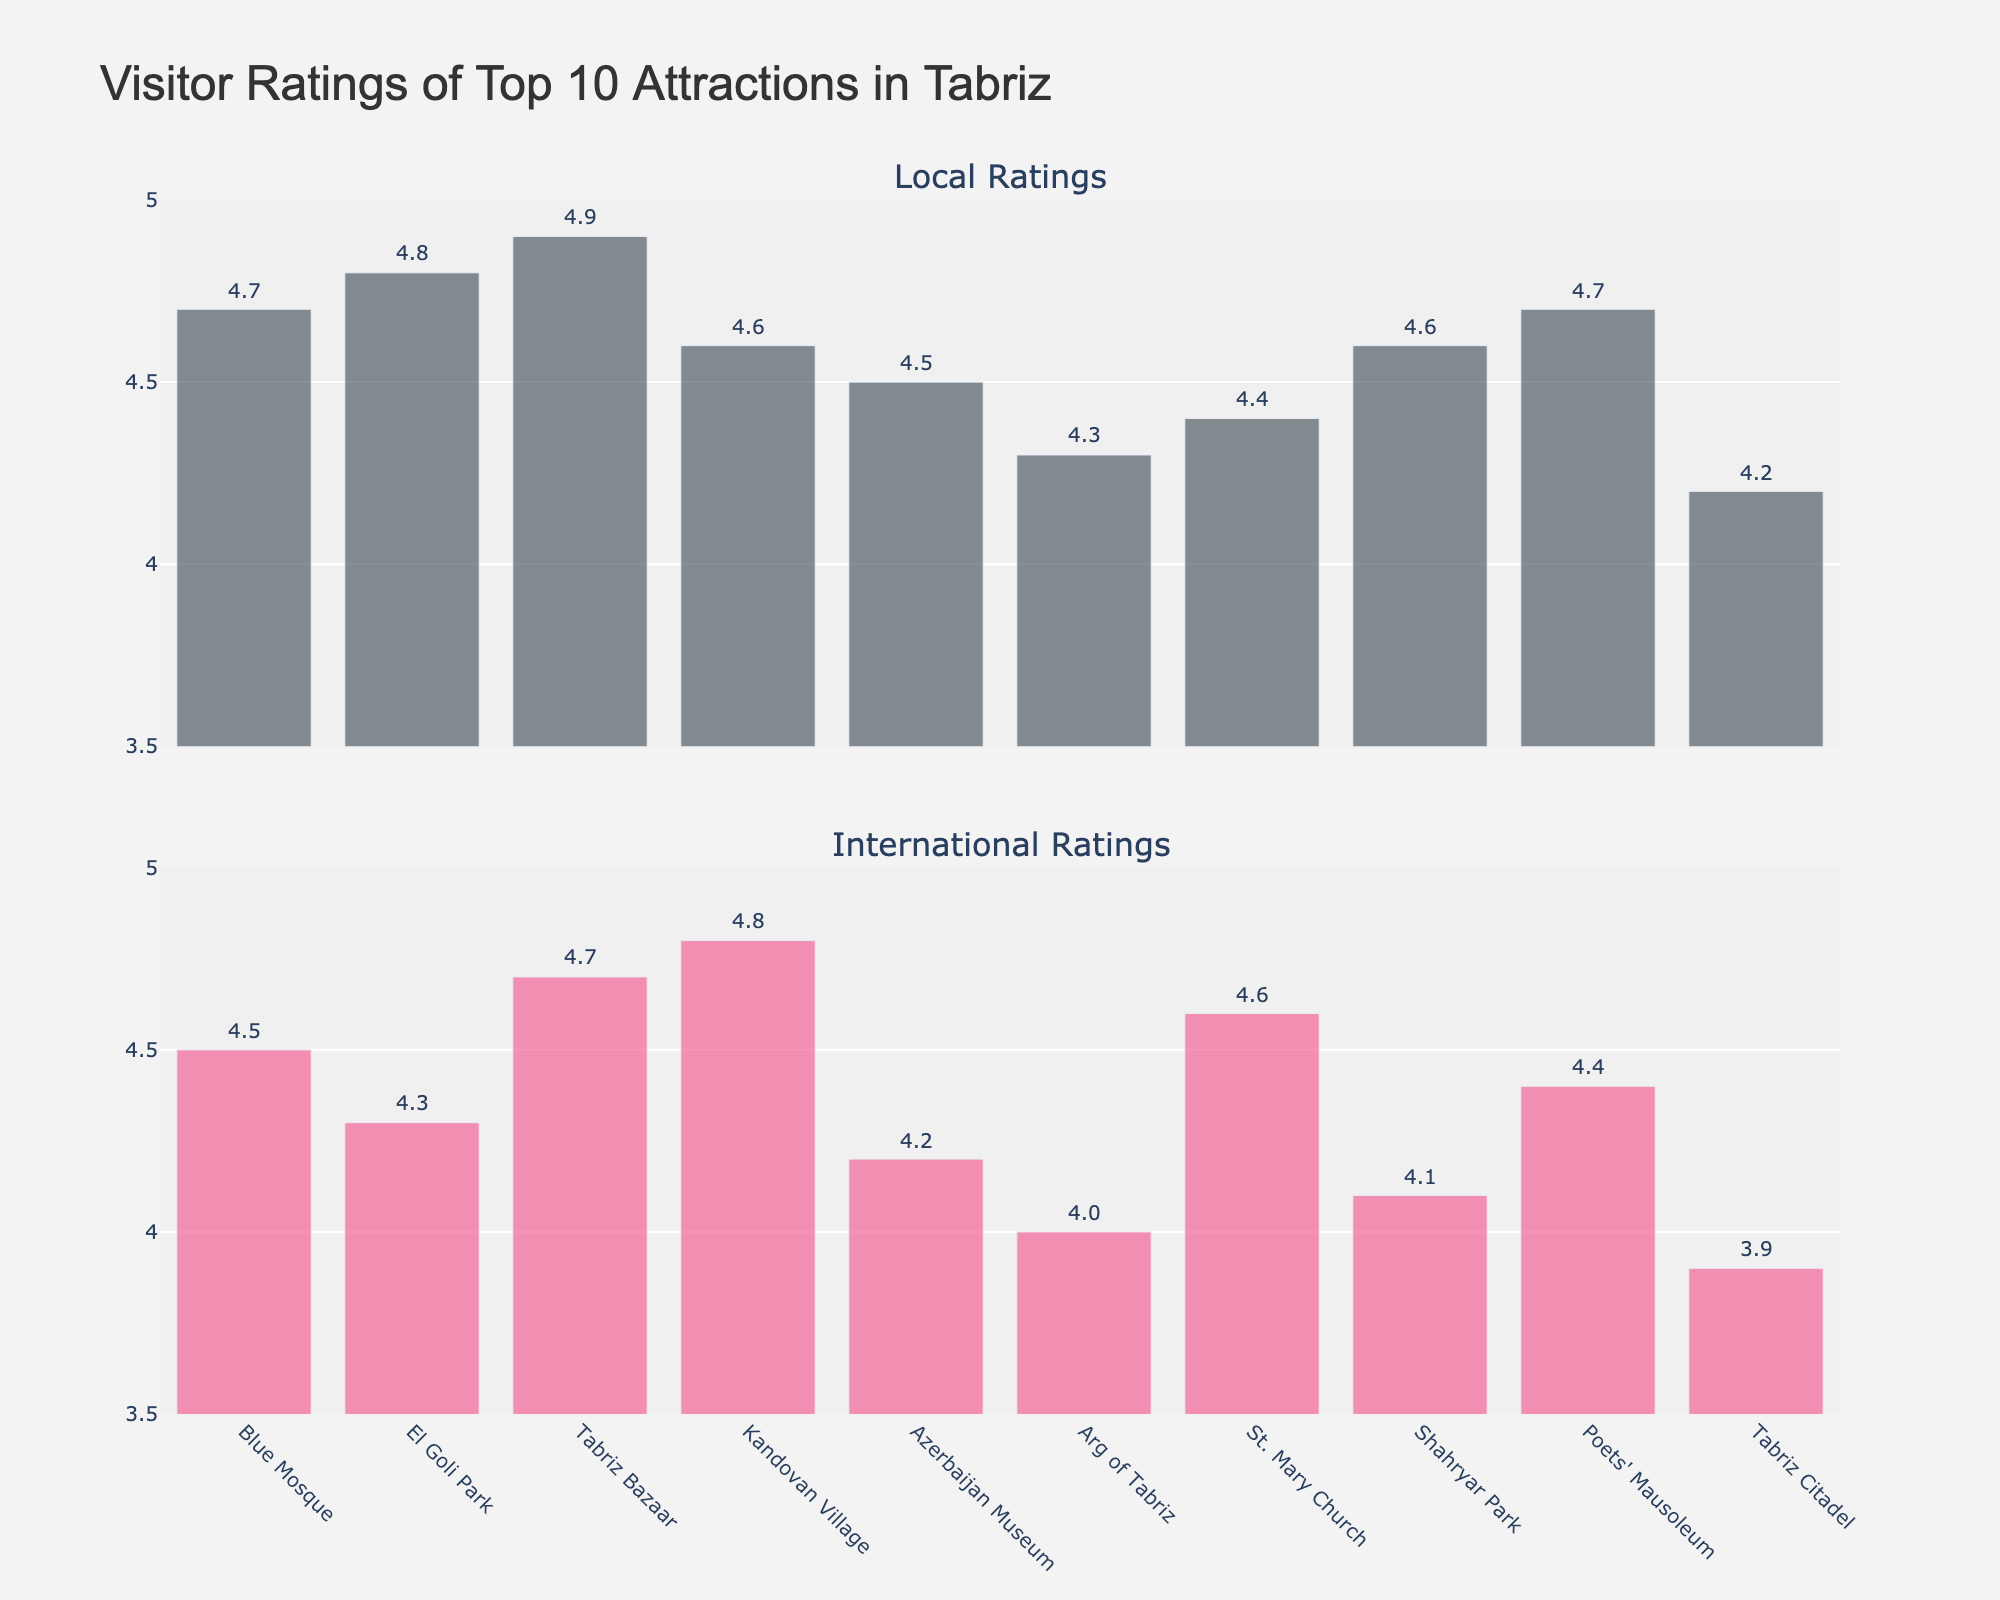What's the title of the figure? The title is usually displayed at the top of the figure. By reading the figure, we can see that the title of this plot is "Visitor Ratings of Top 10 Attractions in Tabriz".
Answer: Visitor Ratings of Top 10 Attractions in Tabriz How many attractions are displayed in the figure? The figure displays bars for each attraction. By counting the bars, we can see there are 10 attractions listed.
Answer: 10 Which attraction has the highest local rating? To find the attraction with the highest local rating, we look at the first subplot and identify the bar with the highest value. "Tabriz Bazaar" has the highest local rating of 4.9.
Answer: Tabriz Bazaar Which attraction has the lowest international rating? To determine the lowest international rating, we check the second subplot and look for the shortest bar. "Tabriz Citadel" has the lowest international rating of 3.9.
Answer: Tabriz Citadel What's the difference between the local and international ratings for El Goli Park? First, identify the ratings from the figure: El Goli Park has a local rating of 4.8 and an international rating of 4.3. Calculate the difference: 4.8 - 4.3 = 0.5.
Answer: 0.5 Which attractions are rated higher by international tourists compared to local tourists? By comparing the bars between the two subplots for each attraction, we see that "Kandovan Village" (4.8 vs 4.6) and "St. Mary Church" (4.6 vs 4.4) are rated higher by international tourists.
Answer: Kandovan Village, St. Mary Church What is the average rating of all attractions for local tourists? Sum the local ratings from the first subplot and divide by the number of attractions: (4.7 + 4.8 + 4.9 + 4.6 + 4.5 + 4.3 + 4.4 + 4.6 + 4.7 + 4.2) / 10 = 45.7 / 10 = 4.57.
Answer: 4.57 How many attractions have a rating of 4.5 or higher from international tourists? Check the second subplot and count the bars that are at 4.5 or higher: "Blue Mosque", "Tabriz Bazaar", "Kandovan Village", "St. Mary Church", and "Poets' Mausoleum" - so there are 5 attractions.
Answer: 5 Which attraction has the smallest difference between local and international ratings? By calculating differences between local and international ratings for each attraction, we find the smallest: "Blue Mosque" has a difference of 0.2 (4.7 - 4.5).
Answer: Blue Mosque What is the median rating for local tourists? Arrange the local ratings in ascending order: 4.2, 4.3, 4.4, 4.5, 4.6, 4.6, 4.7, 4.7, 4.8, 4.9. The median is the middle value of these 10 numbers, which is the average of the 5th and 6th values: (4.6 + 4.6) / 2 = 4.6.
Answer: 4.6 